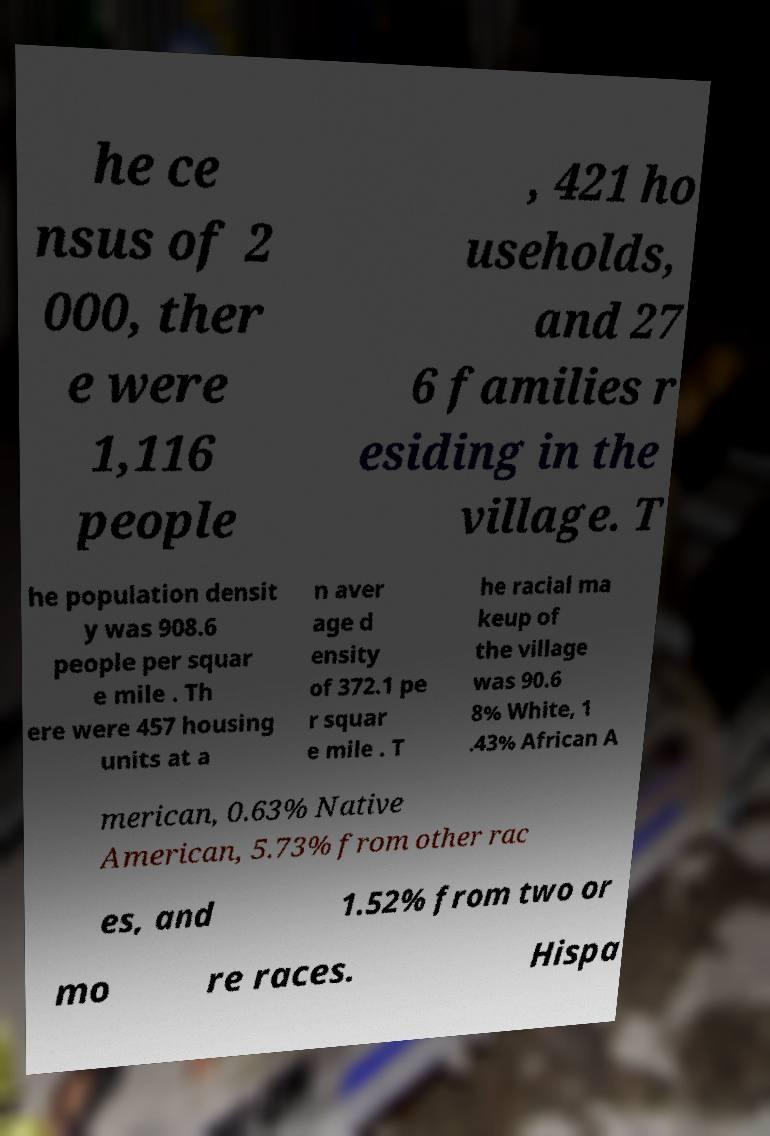Please identify and transcribe the text found in this image. he ce nsus of 2 000, ther e were 1,116 people , 421 ho useholds, and 27 6 families r esiding in the village. T he population densit y was 908.6 people per squar e mile . Th ere were 457 housing units at a n aver age d ensity of 372.1 pe r squar e mile . T he racial ma keup of the village was 90.6 8% White, 1 .43% African A merican, 0.63% Native American, 5.73% from other rac es, and 1.52% from two or mo re races. Hispa 